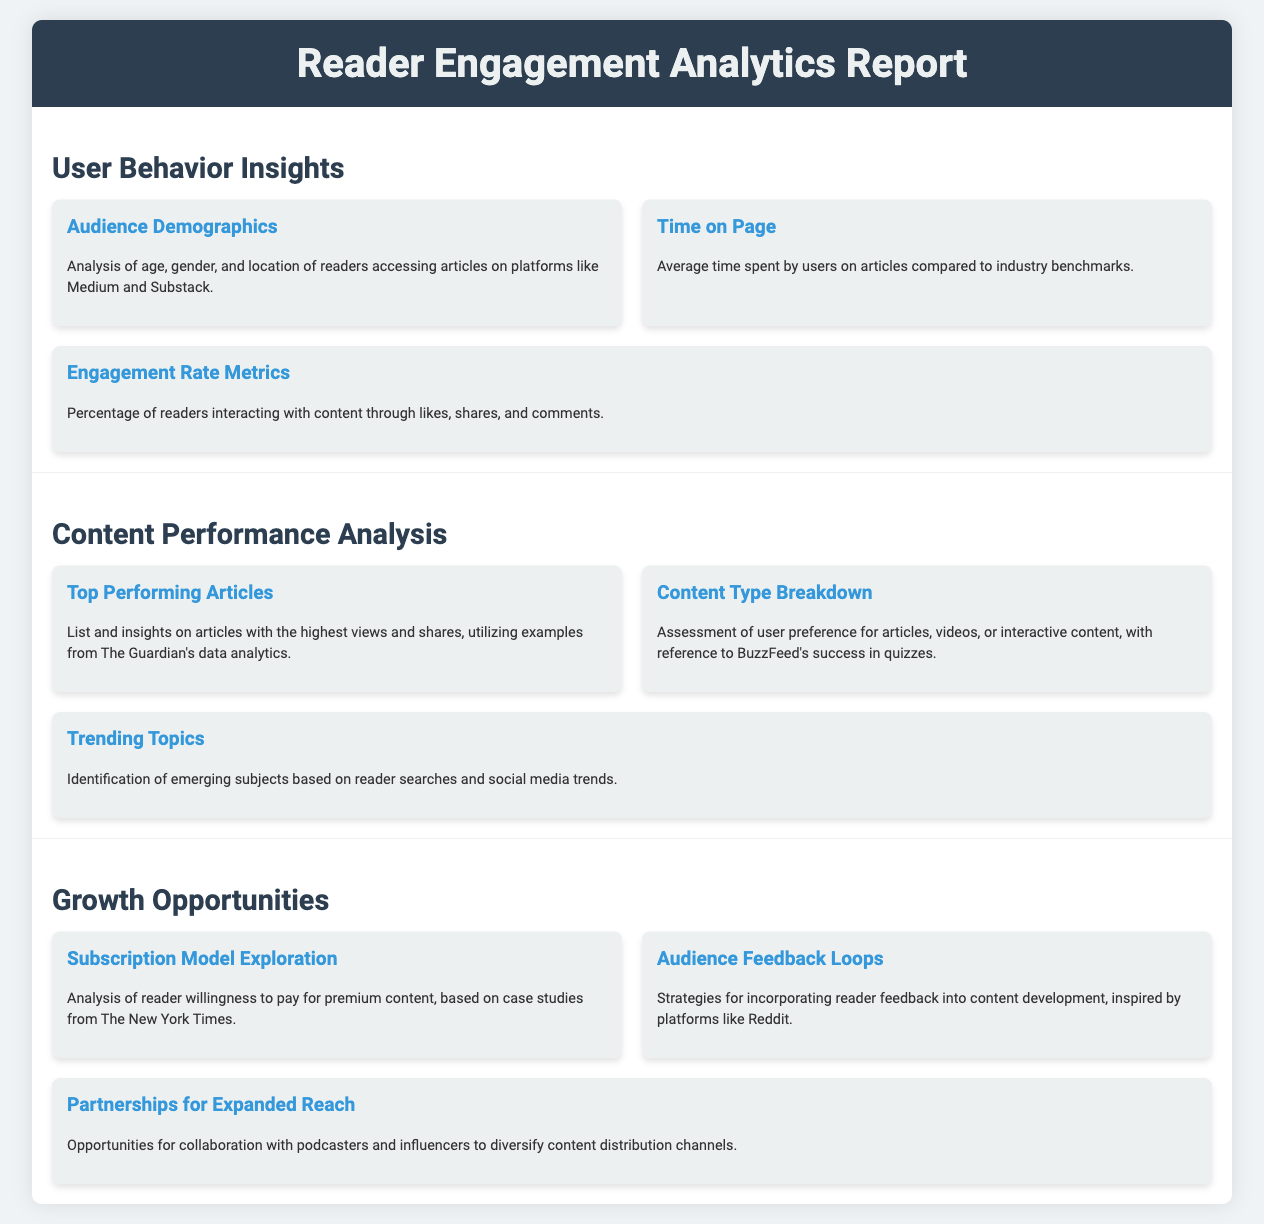what are the audience demographics? The audience demographics provide analysis of age, gender, and location of readers accessing articles on platforms like Medium and Substack.
Answer: age, gender, and location what is the average time spent by users on articles? The average time spent by users on articles is compared to industry benchmarks.
Answer: compared to industry benchmarks what percentage of readers interact with content? The engagement rate metrics detail the percentage of readers interacting with content through likes, shares, and comments.
Answer: percentage of readers which articles perform the best? The top performing articles section lists and provides insights on articles with the highest views and shares.
Answer: articles with the highest views and shares what type of content do users prefer? The content type breakdown assesses user preference for articles, videos, or interactive content.
Answer: articles, videos, or interactive content what strategies can be used for audience feedback? The audience feedback loops section discusses strategies for incorporating reader feedback into content development.
Answer: incorporating reader feedback what opportunity is explored regarding subscriptions? The subscription model exploration analyzes reader willingness to pay for premium content.
Answer: willingness to pay for premium content which company's data analytics is referenced? Insights on top performing articles utilize examples from The Guardian's data analytics.
Answer: The Guardian what collaborations are discussed for expanding reach? The partnerships for expanded reach section discusses opportunities for collaboration with podcasters and influencers.
Answer: collaboration with podcasters and influencers 